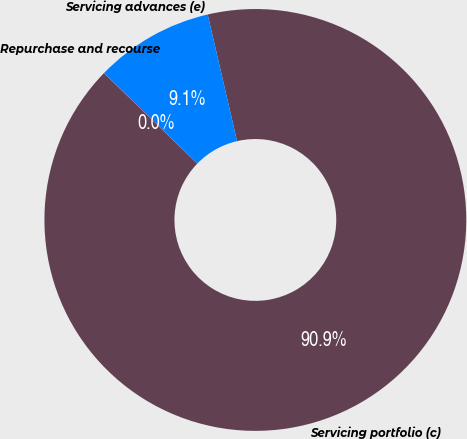<chart> <loc_0><loc_0><loc_500><loc_500><pie_chart><fcel>Servicing portfolio (c)<fcel>Servicing advances (e)<fcel>Repurchase and recourse<nl><fcel>90.88%<fcel>9.1%<fcel>0.02%<nl></chart> 